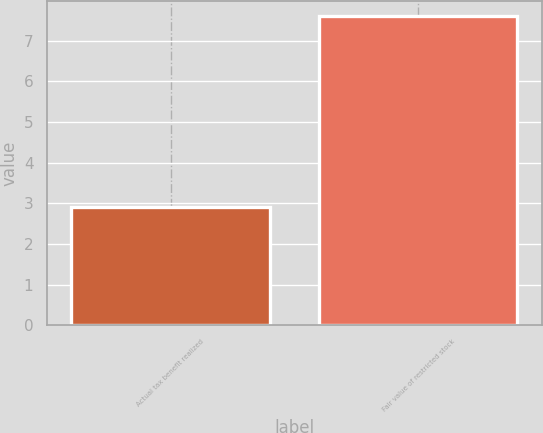Convert chart to OTSL. <chart><loc_0><loc_0><loc_500><loc_500><bar_chart><fcel>Actual tax benefit realized<fcel>Fair value of restricted stock<nl><fcel>2.9<fcel>7.6<nl></chart> 